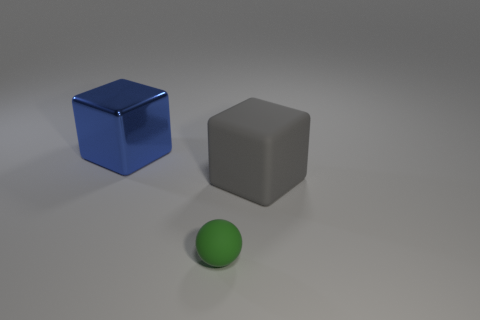Can you describe the lighting in the image? The image is illuminated by a soft, diffuse light source coming from the top right, as indicated by the shadows directly opposite each object, creating a gentle contrast and a calm atmosphere. 